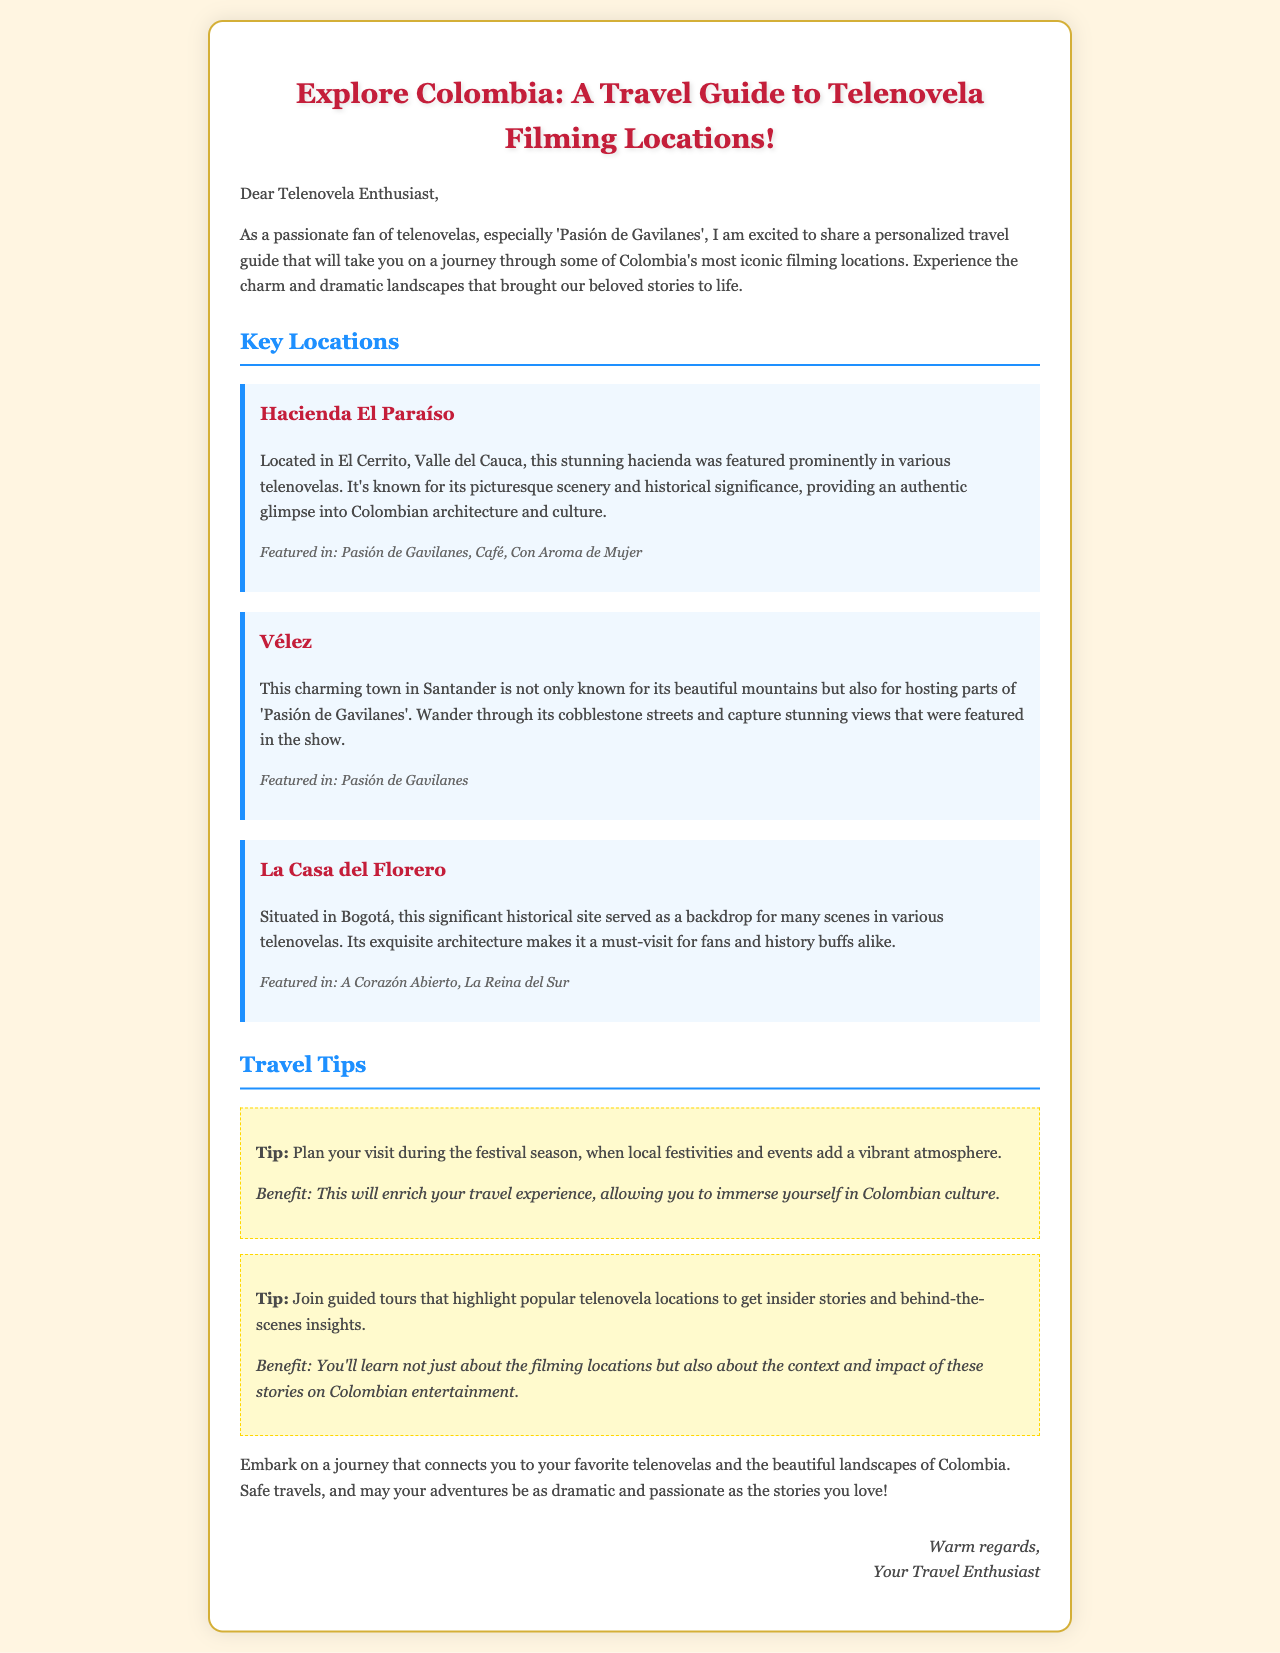What is the title of the travel guide? The title of the travel guide is presented prominently at the top of the email.
Answer: Explore Colombia: A Travel Guide to Telenovela Filming Locations! What is the first location mentioned in the guide? The first location mentioned is detailed in the "Key Locations" section of the email.
Answer: Hacienda El Paraíso Which telenovela is specifically mentioned in relation to Vélez? The telenovela reference for Vélez is found in the description of that location.
Answer: Pasión de Gavilanes What season is recommended for visiting telenovela filming locations? The email suggests visiting during a specific time for an enhanced experience.
Answer: Festival season How many tips are provided in the travel guide? The number of tips can be counted in the "Travel Tips" section.
Answer: 2 What is the author’s closing remark? The author provides a warm closing statement at the end of the email.
Answer: Warm regards Which city is La Casa del Florero located in? The city of La Casa del Florero is mentioned in the description of that location.
Answer: Bogotá What type of architecture does La Casa del Florero have? The type of architecture is described in the context of its historical significance.
Answer: Exquisite architecture 